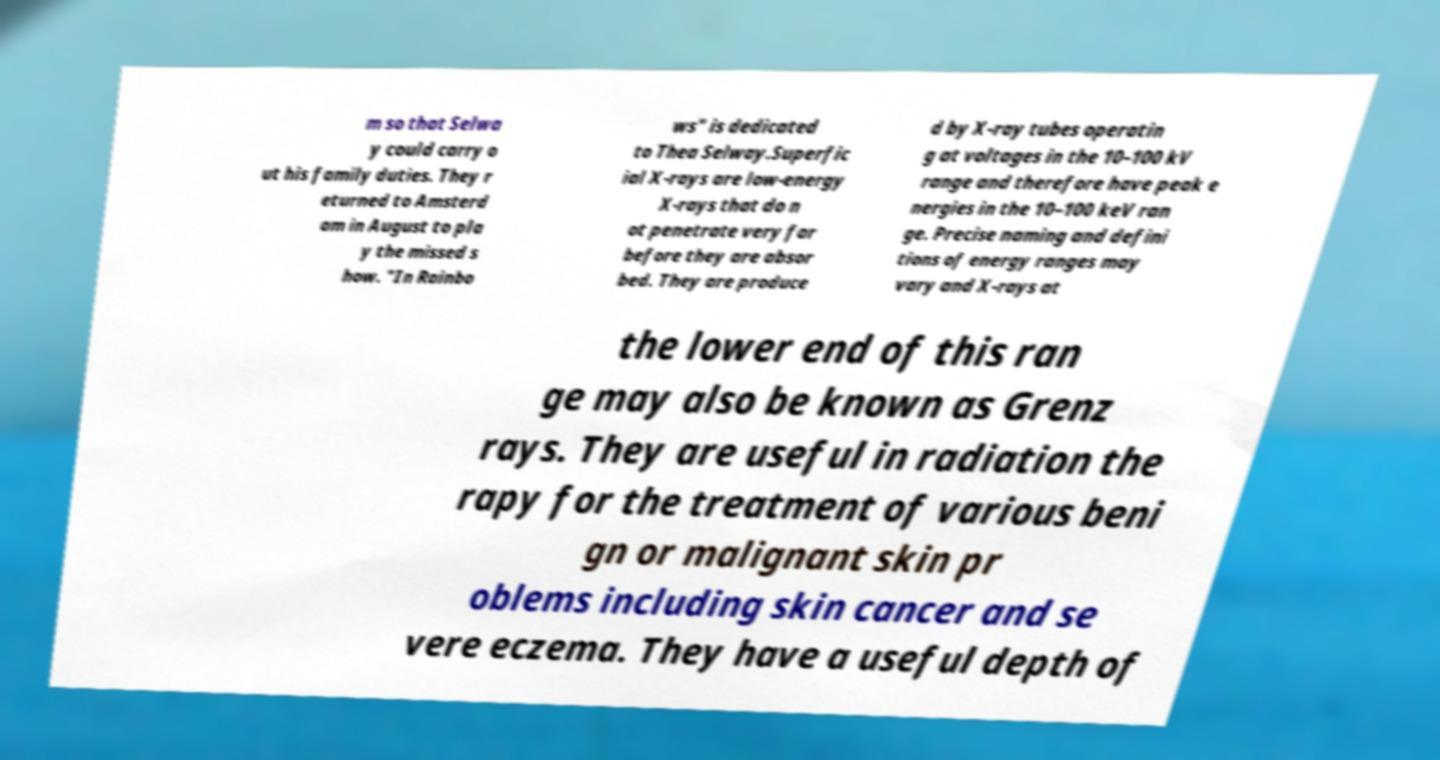Could you extract and type out the text from this image? m so that Selwa y could carry o ut his family duties. They r eturned to Amsterd am in August to pla y the missed s how. "In Rainbo ws" is dedicated to Thea Selway.Superfic ial X-rays are low-energy X-rays that do n ot penetrate very far before they are absor bed. They are produce d by X-ray tubes operatin g at voltages in the 10–100 kV range and therefore have peak e nergies in the 10–100 keV ran ge. Precise naming and defini tions of energy ranges may vary and X-rays at the lower end of this ran ge may also be known as Grenz rays. They are useful in radiation the rapy for the treatment of various beni gn or malignant skin pr oblems including skin cancer and se vere eczema. They have a useful depth of 